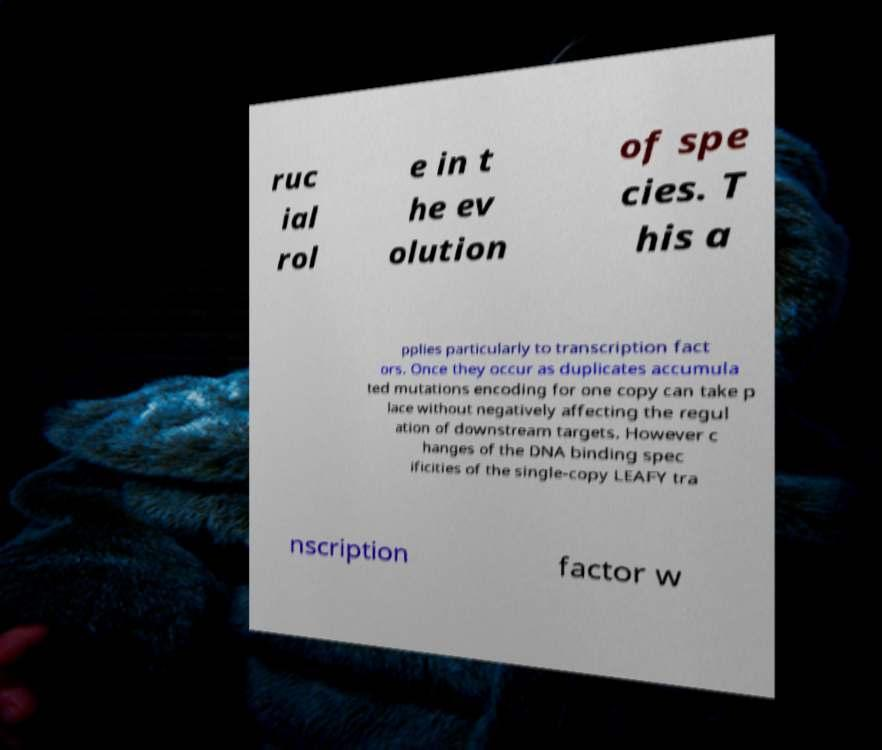Please read and relay the text visible in this image. What does it say? ruc ial rol e in t he ev olution of spe cies. T his a pplies particularly to transcription fact ors. Once they occur as duplicates accumula ted mutations encoding for one copy can take p lace without negatively affecting the regul ation of downstream targets. However c hanges of the DNA binding spec ificities of the single-copy LEAFY tra nscription factor w 